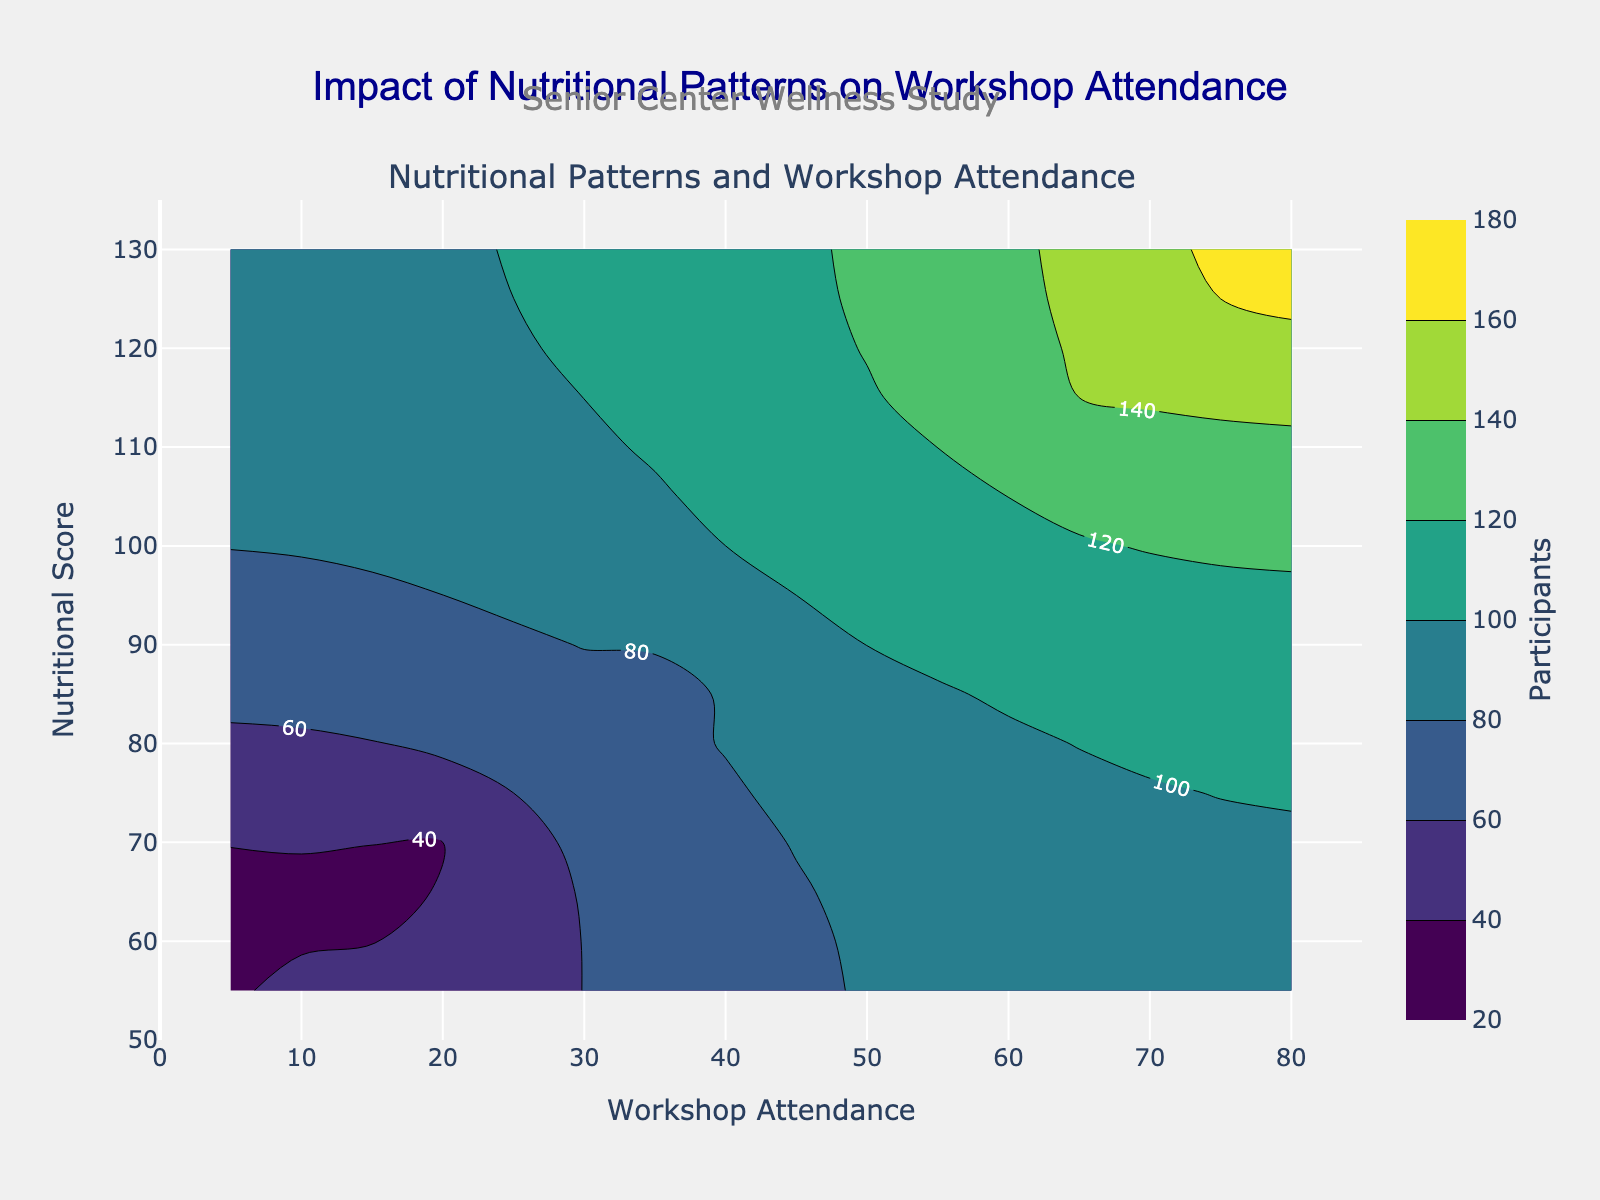What is the title of the plot? The title appears at the top center of the plot. It reads 'Impact of Nutritional Patterns on Workshop Attendance.'
Answer: Impact of Nutritional Patterns on Workshop Attendance What does the x-axis represent? The x-axis title is displayed at the bottom of the plot, indicating it represents 'Workshop Attendance.'
Answer: Workshop Attendance What does the y-axis represent? The y-axis title is displayed along the left side of the plot, indicating it represents 'Nutritional Score.'
Answer: Nutritional Score What color is used to indicate a higher number of participants on the color scale? The color scale shown on the right side of the plot ranges from dark purple to yellow-green, with yellow-green representing a higher number of participants.
Answer: Yellow-green At what Nutritional Score does Workshop Attendance reach 40 participants? The contour labels on the plot show attendance levels. At Nutritional Score of 90, the contour label reads 40 participants.
Answer: 90 Which Workshop Attendance level corresponds to 70 participants, and what is the Nutritional Score at that point? The contour for 70 participants intersects the Nutritional Score of 85 and the Workshop Attendance level of 35.
Answer: Workshop Attendance: 35, Nutritional Score: 85 At the Nutritional Score of 105, what is the approximate number of workshop participants when Workshop Attendance is 45? Locate the intersection of Nutritional Score 105 and Workshop Attendance 45. The contour label near this point shows 100 participants.
Answer: 100 What is the general trend between Nutritional Score and Workshop Attendance in terms of participants? Observing the contours, as both Nutritional Score and Workshop Attendance increase, the number of participants also increases.
Answer: Increasing Nutritional Score and Workshop Attendance correlates with more participants Is there a Workshop Attendance level that consistently shows more participants as the Nutritional Score increases? Workshop Attendance levels can be compared across the same Nutritional Score range; each level tends to show an increase in participants as the Nutritional Score increases.
Answer: Yes, all levels tend to show more participants What is the approximate Nutritional Score and Workshop Attendance when participants hit 150? Locate the contour label for 150 participants. It appears around Nutritional Score 120 and Workshop Attendance 70.
Answer: Nutritional Score: 120, Workshop Attendance: 70 